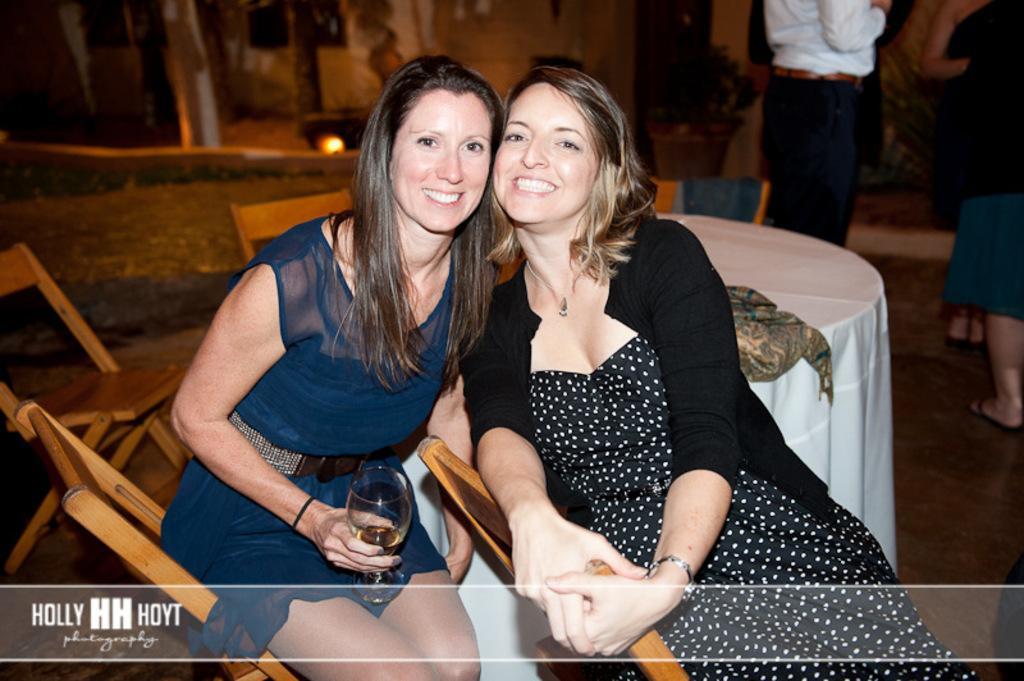Can you describe this image briefly? In this picture there are two women who are smiling and both of them are sitting on the chair, beside them we can see the table and others chairs. She is holding a wine glass. In the top right corner there is a man who is standing near to the plant. At the top there is a building. On the right there is a woman who is wearing black dress. 